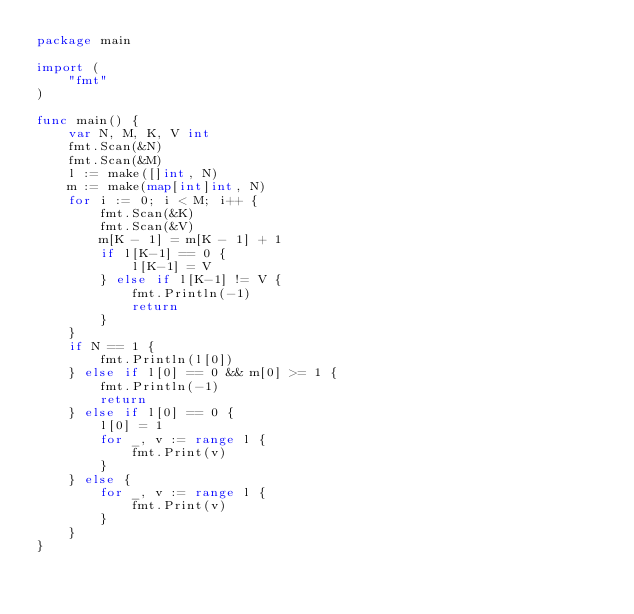<code> <loc_0><loc_0><loc_500><loc_500><_Go_>package main
 
import (
	"fmt"
)
 
func main() {
	var N, M, K, V int
	fmt.Scan(&N)
	fmt.Scan(&M)
	l := make([]int, N)
	m := make(map[int]int, N)
	for i := 0; i < M; i++ {
	    fmt.Scan(&K)
		fmt.Scan(&V)
		m[K - 1] = m[K - 1] + 1
		if l[K-1] == 0 {
			l[K-1] = V
		} else if l[K-1] != V {
			fmt.Println(-1)
			return
		}
	}
	if N == 1 {
		fmt.Println(l[0])
	} else if l[0] == 0 && m[0] >= 1 {
		fmt.Println(-1)
		return
	} else if l[0] == 0 {
		l[0] = 1
		for _, v := range l {
			fmt.Print(v)
		}
	} else {
		for _, v := range l {
			fmt.Print(v)
		}
	}
}
</code> 